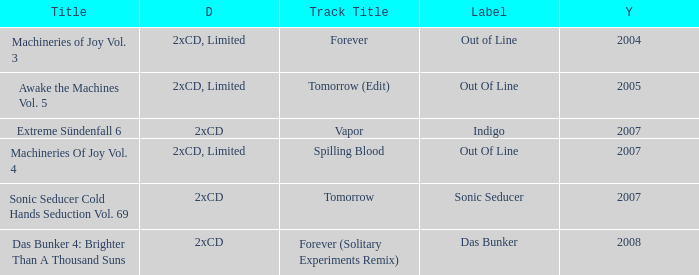Which label has a year older than 2004 and a 2xcd detail as well as the sonic seducer cold hands seduction vol. 69 title? Sonic Seducer. 